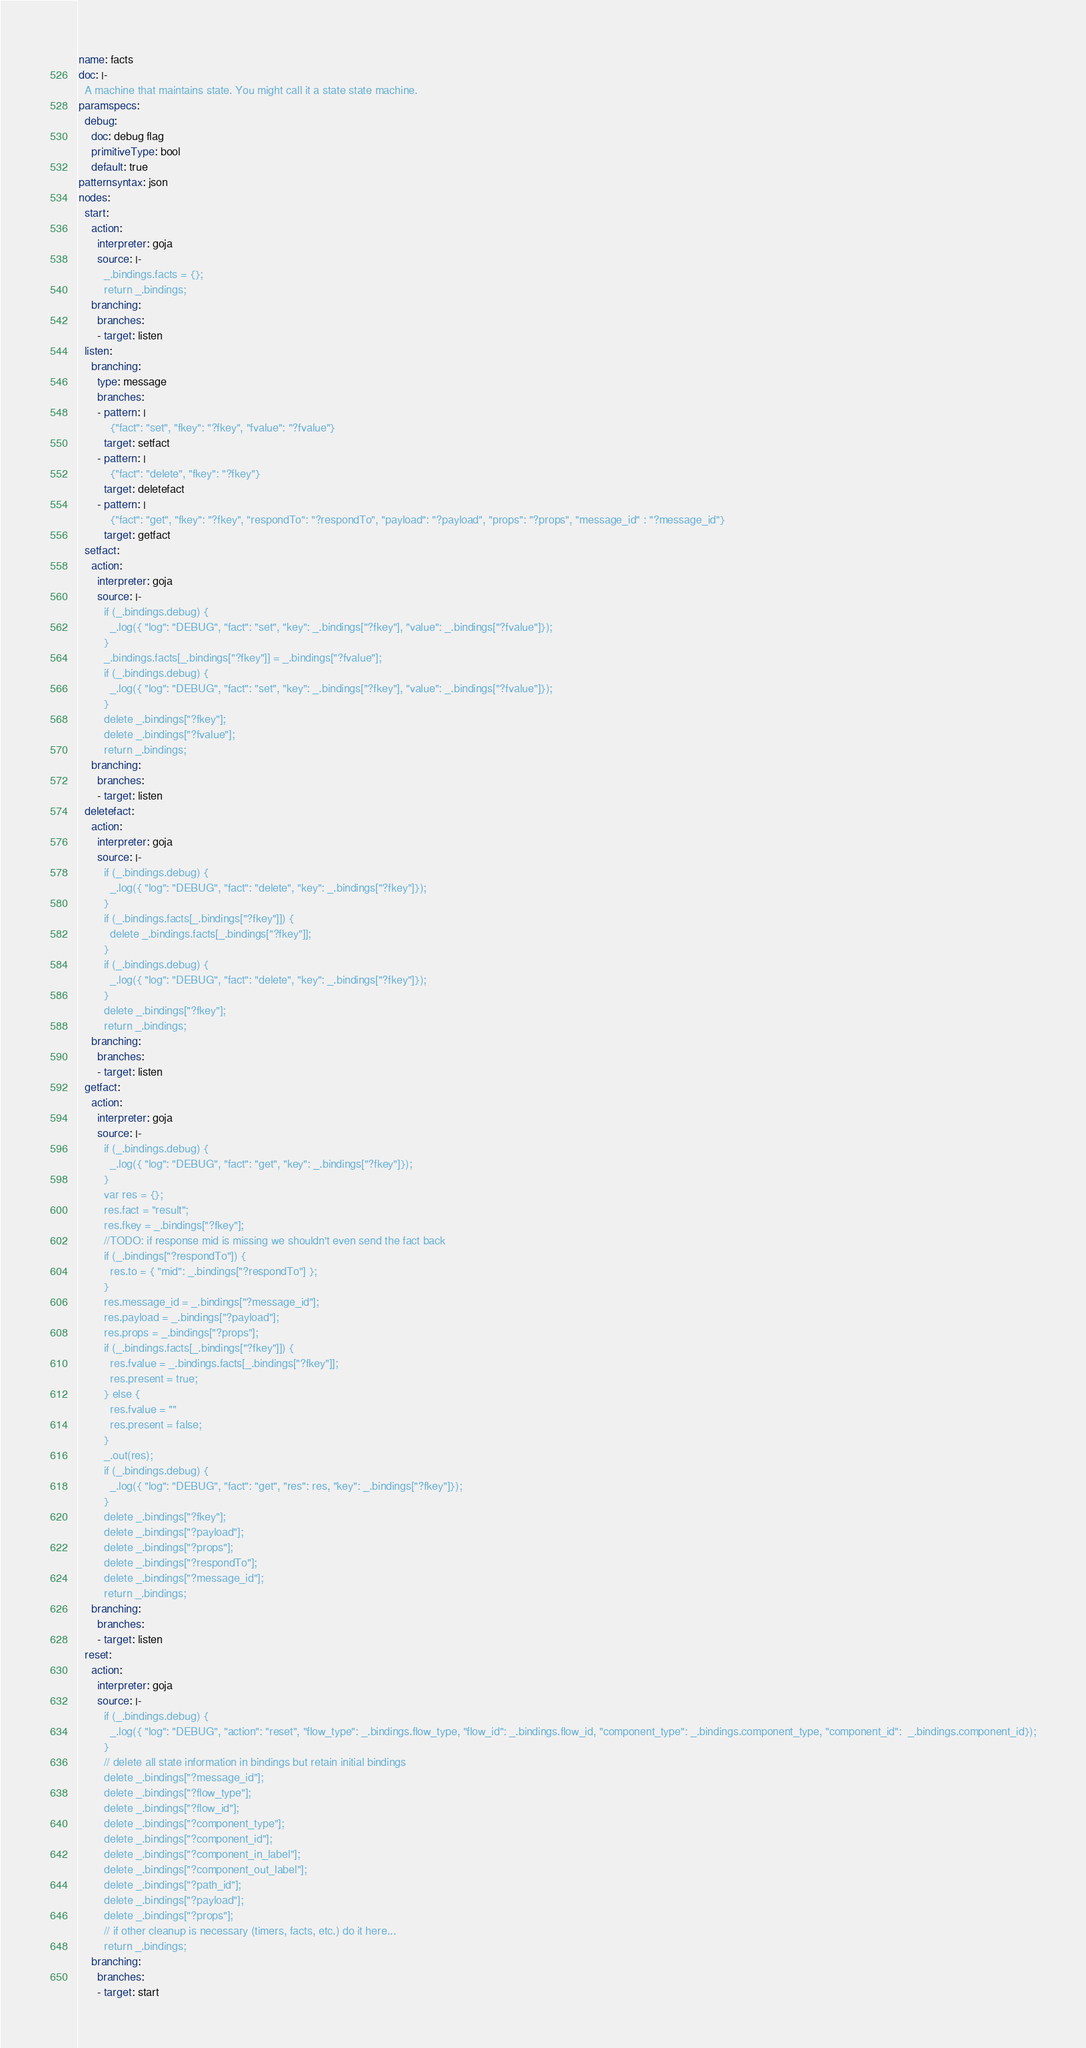<code> <loc_0><loc_0><loc_500><loc_500><_YAML_>name: facts
doc: |-
  A machine that maintains state. You might call it a state state machine.
paramspecs:
  debug:
    doc: debug flag
    primitiveType: bool
    default: true
patternsyntax: json
nodes:
  start:
    action:
      interpreter: goja
      source: |-
        _.bindings.facts = {};
        return _.bindings;
    branching:
      branches:
      - target: listen
  listen:
    branching:
      type: message
      branches:
      - pattern: |
          {"fact": "set", "fkey": "?fkey", "fvalue": "?fvalue"}
        target: setfact
      - pattern: |
          {"fact": "delete", "fkey": "?fkey"}
        target: deletefact
      - pattern: |
          {"fact": "get", "fkey": "?fkey", "respondTo": "?respondTo", "payload": "?payload", "props": "?props", "message_id" : "?message_id"}
        target: getfact
  setfact:
    action:
      interpreter: goja
      source: |-
        if (_.bindings.debug) {
          _.log({ "log": "DEBUG", "fact": "set", "key": _.bindings["?fkey"], "value": _.bindings["?fvalue"]});
        }
        _.bindings.facts[_.bindings["?fkey"]] = _.bindings["?fvalue"];
        if (_.bindings.debug) {
          _.log({ "log": "DEBUG", "fact": "set", "key": _.bindings["?fkey"], "value": _.bindings["?fvalue"]});
        }
        delete _.bindings["?fkey"];
        delete _.bindings["?fvalue"];
        return _.bindings;
    branching:
      branches:
      - target: listen
  deletefact:
    action:
      interpreter: goja
      source: |-
        if (_.bindings.debug) {
          _.log({ "log": "DEBUG", "fact": "delete", "key": _.bindings["?fkey"]});
        }
        if (_.bindings.facts[_.bindings["?fkey"]]) {
          delete _.bindings.facts[_.bindings["?fkey"]];
        }
        if (_.bindings.debug) {
          _.log({ "log": "DEBUG", "fact": "delete", "key": _.bindings["?fkey"]});
        }
        delete _.bindings["?fkey"];
        return _.bindings;
    branching:
      branches:
      - target: listen
  getfact:
    action:
      interpreter: goja
      source: |-
        if (_.bindings.debug) {
          _.log({ "log": "DEBUG", "fact": "get", "key": _.bindings["?fkey"]});
        }
        var res = {};
        res.fact = "result";
        res.fkey = _.bindings["?fkey"];
        //TODO: if response mid is missing we shouldn't even send the fact back
        if (_.bindings["?respondTo"]) {
          res.to = { "mid": _.bindings["?respondTo"] };
        }
        res.message_id = _.bindings["?message_id"];
        res.payload = _.bindings["?payload"];
        res.props = _.bindings["?props"];
        if (_.bindings.facts[_.bindings["?fkey"]]) {
          res.fvalue = _.bindings.facts[_.bindings["?fkey"]];
          res.present = true;
        } else {
          res.fvalue = ""
          res.present = false;
        }
        _.out(res);
        if (_.bindings.debug) {
          _.log({ "log": "DEBUG", "fact": "get", "res": res, "key": _.bindings["?fkey"]});
        }
        delete _.bindings["?fkey"];
        delete _.bindings["?payload"];
        delete _.bindings["?props"];
        delete _.bindings["?respondTo"];
        delete _.bindings["?message_id"];
        return _.bindings;
    branching:
      branches:
      - target: listen
  reset:
    action:
      interpreter: goja
      source: |-
        if (_.bindings.debug) {
          _.log({ "log": "DEBUG", "action": "reset", "flow_type": _.bindings.flow_type, "flow_id": _.bindings.flow_id, "component_type": _.bindings.component_type, "component_id":  _.bindings.component_id});
        }
        // delete all state information in bindings but retain initial bindings
        delete _.bindings["?message_id"];
        delete _.bindings["?flow_type"];
        delete _.bindings["?flow_id"];
        delete _.bindings["?component_type"];
        delete _.bindings["?component_id"];
        delete _.bindings["?component_in_label"];
        delete _.bindings["?component_out_label"];
        delete _.bindings["?path_id"];
        delete _.bindings["?payload"];
        delete _.bindings["?props"];
        // if other cleanup is necessary (timers, facts, etc.) do it here...
        return _.bindings;
    branching:
      branches:
      - target: start
</code> 